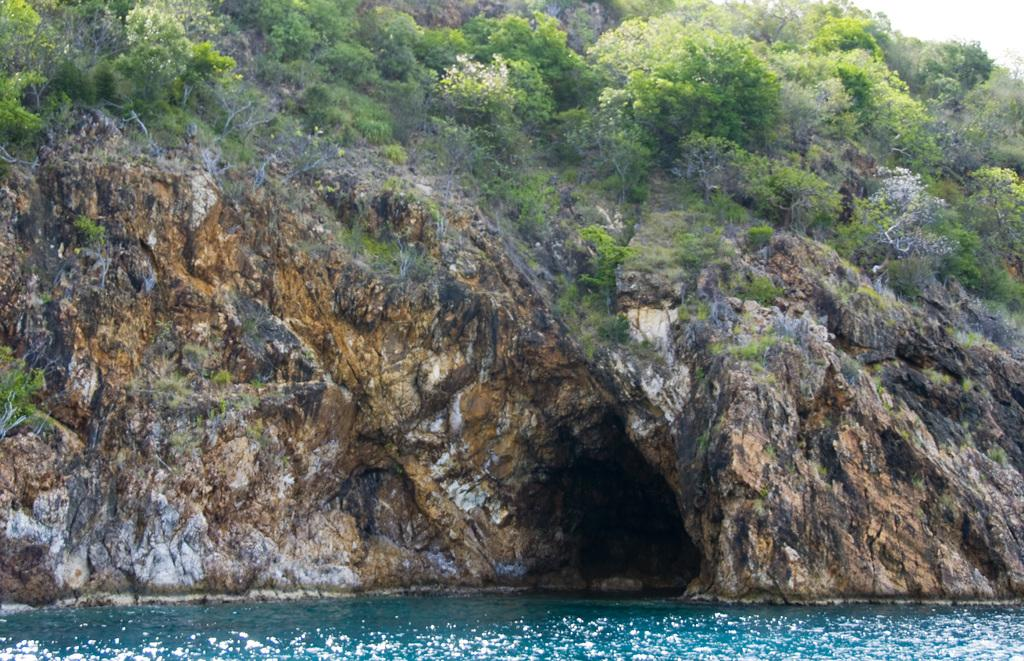What type of natural environment is depicted in the image? The image features a sea, a cave, a hill, and many trees, indicating a coastal or beach setting. Can you describe the geological features in the image? There is a cave and a hill visible in the image. What type of vegetation is present in the image? There are many trees in the image. How many tickets are needed to enter the cave in the image? There is no mention of tickets or any entrance fee in the image; it simply shows a cave and other natural elements. 